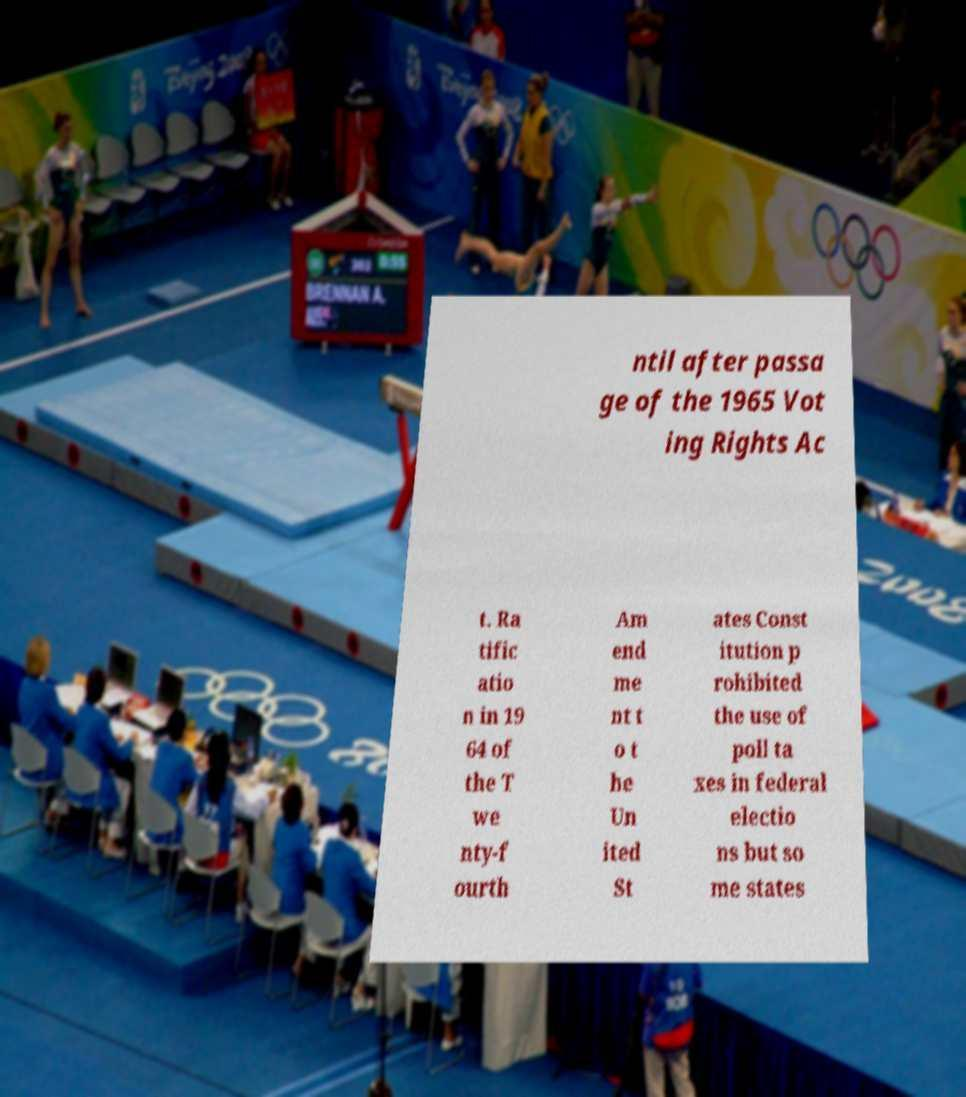I need the written content from this picture converted into text. Can you do that? ntil after passa ge of the 1965 Vot ing Rights Ac t. Ra tific atio n in 19 64 of the T we nty-f ourth Am end me nt t o t he Un ited St ates Const itution p rohibited the use of poll ta xes in federal electio ns but so me states 